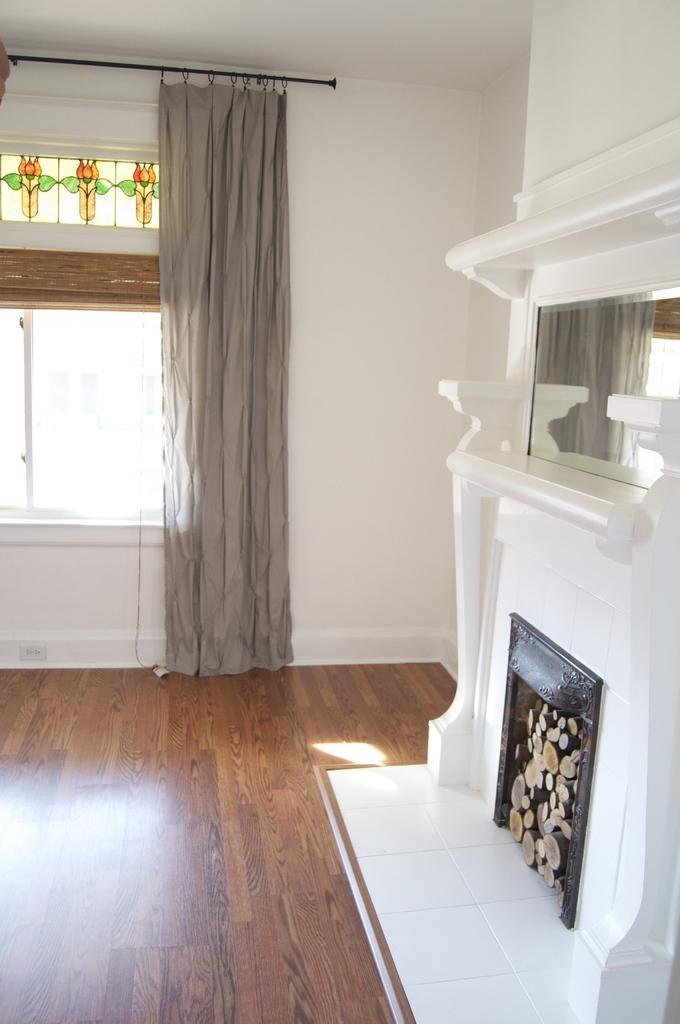Could you give a brief overview of what you see in this image? In this image there is a wooden floor and there is a fireplace, on the fireplace there is a mirror on the wall and there are curtains on the glass windows. 